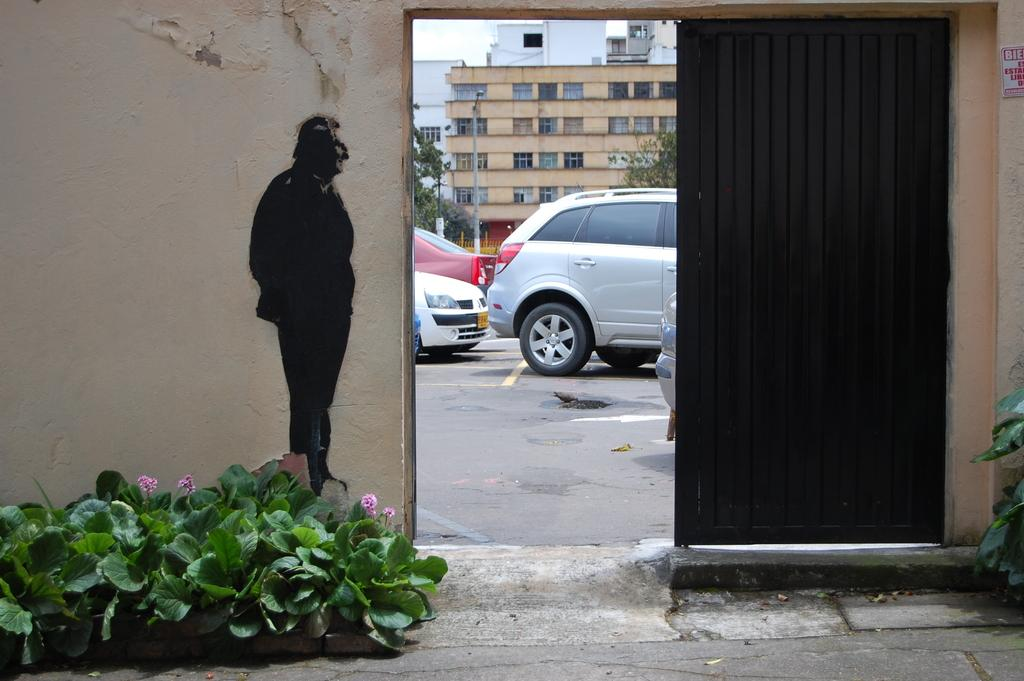What is located in the center of the image? There is a door in the center of the image. What can be seen through the door? Buildings, cars, and a road are visible through the door. What is another object present in the image? There is a painting in the image. What type of vegetation is at the bottom of the image? Plants are present at the bottom of the image. What type of blade is being used to cut the plants in the image? There is no blade present in the image, and the plants are not being cut. 